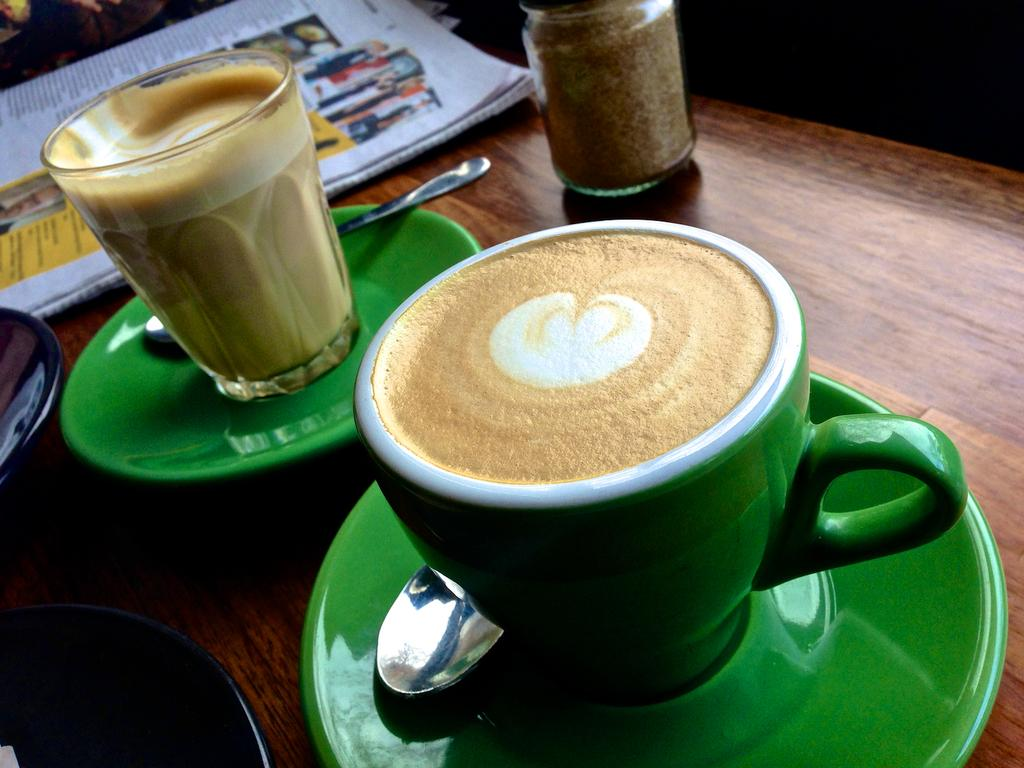What is in the cup that is visible in the image? There is coffee in the cup in the image. What is the saucer used for in the image? The saucer is likely used to hold the cup of coffee in the image. What utensil is visible in the image? There is a spoon in the image. What other beverage container is present in the image? There is a glass in the image. What reading materials are present in the image? There is a newspaper and a book in the image. What other object is present in the image? There is a jar in the image. Where are all these objects located? All objects are on a table in the image. How much soup is in the jar in the image? There is no soup present in the image; it is a jar, not a container for soup. 